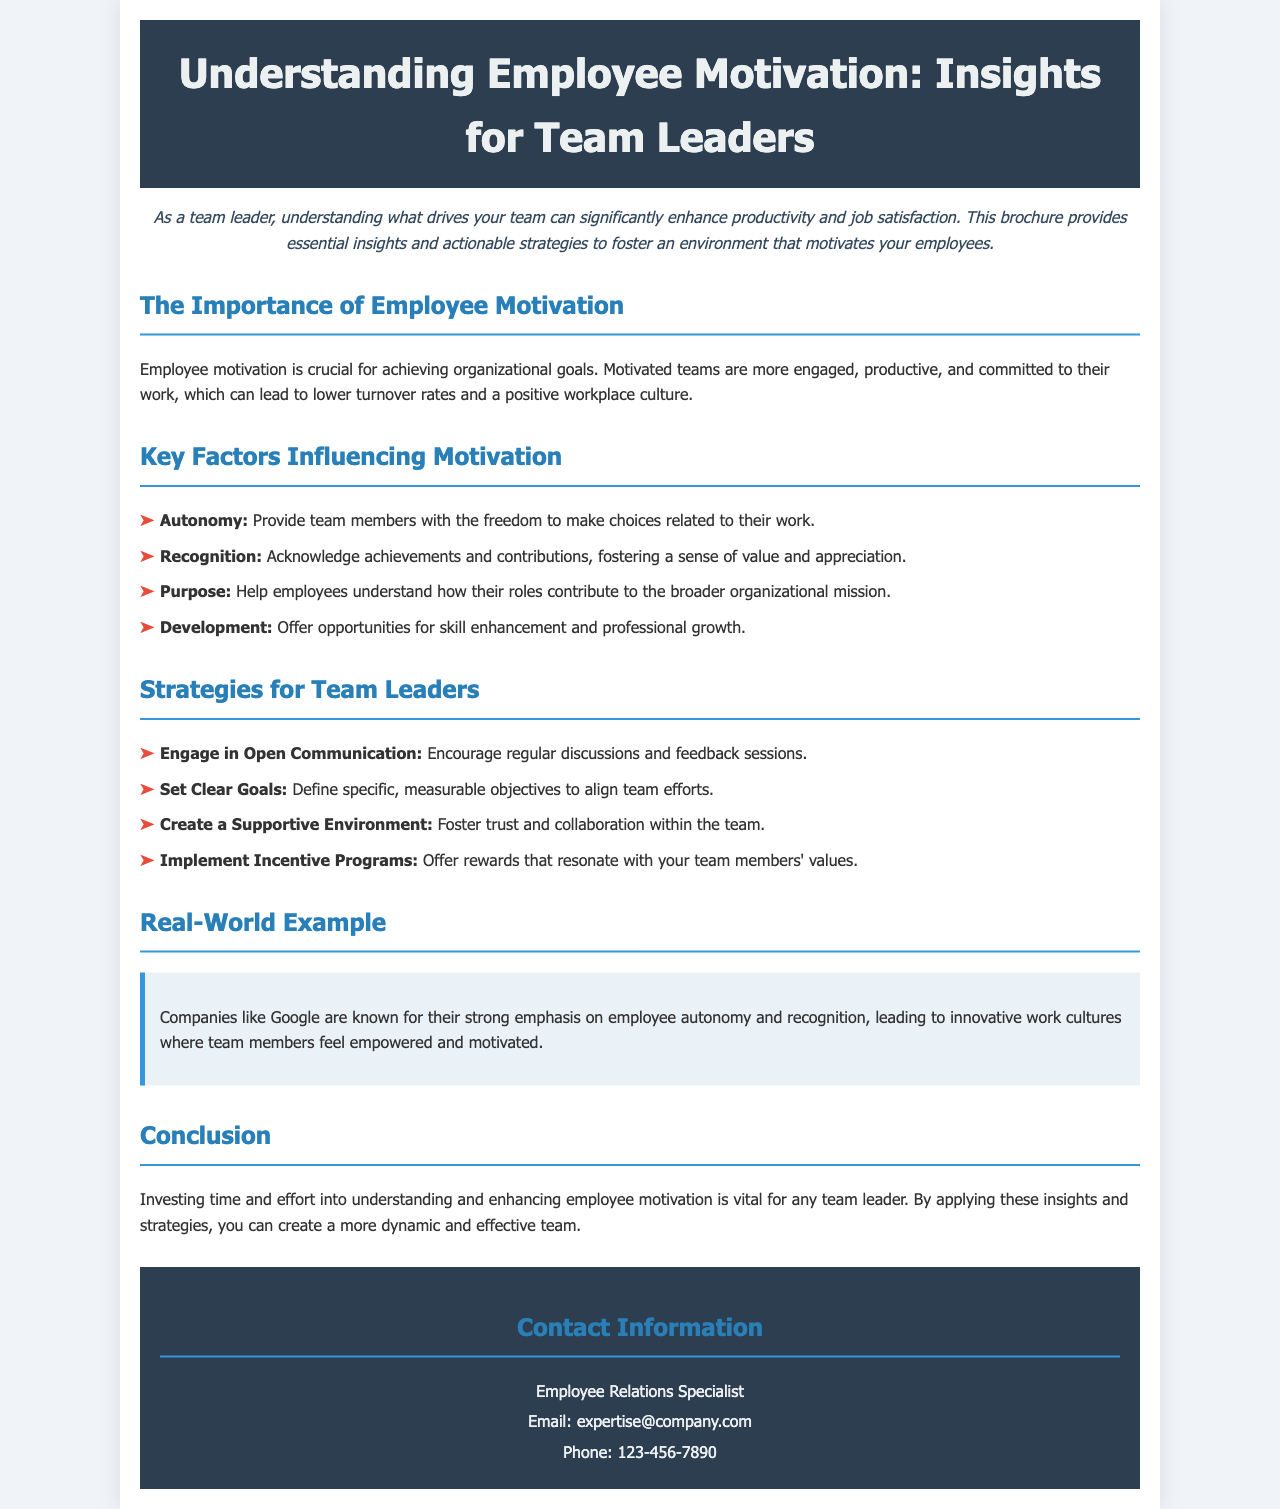What is the main title of the brochure? The main title is located at the top of the document, establishing the topic clearly.
Answer: Understanding Employee Motivation: Insights for Team Leaders Who is the contact person for the brochure? The contact person is mentioned in the contact information section of the document.
Answer: Employee Relations Specialist What are the key factors influencing motivation? The document outlines four specific factors crucial for employee motivation.
Answer: Autonomy, Recognition, Purpose, Development Name a company known for emphasizing employee autonomy. The document provides an example of a company that exemplifies this approach.
Answer: Google What is one strategy for team leaders mentioned in the brochure? The document includes several strategies for team leaders to enhance motivation.
Answer: Engage in Open Communication How can employee motivation impact turnover rates? The document states the effect of motivation on employee retention.
Answer: Lower turnover rates What is the color scheme used in the header section? The header section has specific colors that create a professional appearance.
Answer: Dark blue and light gray What does the example provided in the brochure highlight? The real-world example emphasizes practical implementation of motivational factors.
Answer: Employee autonomy and recognition 